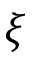Convert formula to latex. <formula><loc_0><loc_0><loc_500><loc_500>\xi</formula> 